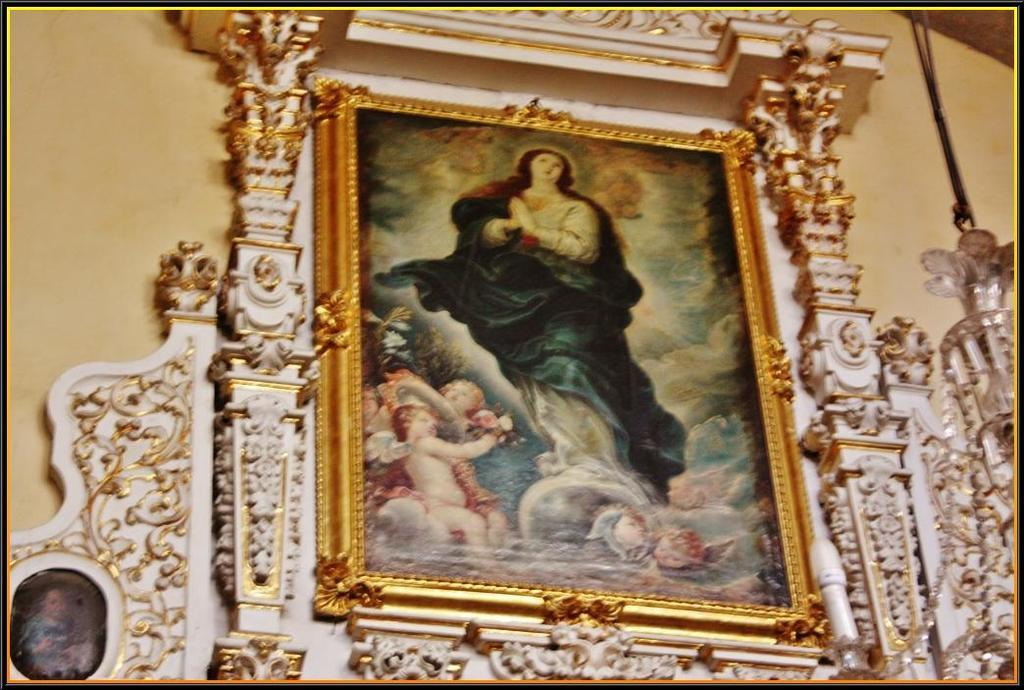What object can be seen in the image that typically holds a photo? There is a photo frame in the image. Where is the photo frame located? The photo frame is fixed on a wall. What color is the wall behind the photo frame? The wall in the background is cream-colored. Can you see a lake in the background of the image? There is no lake visible in the image; it only shows a photo frame fixed on a cream-colored wall. 